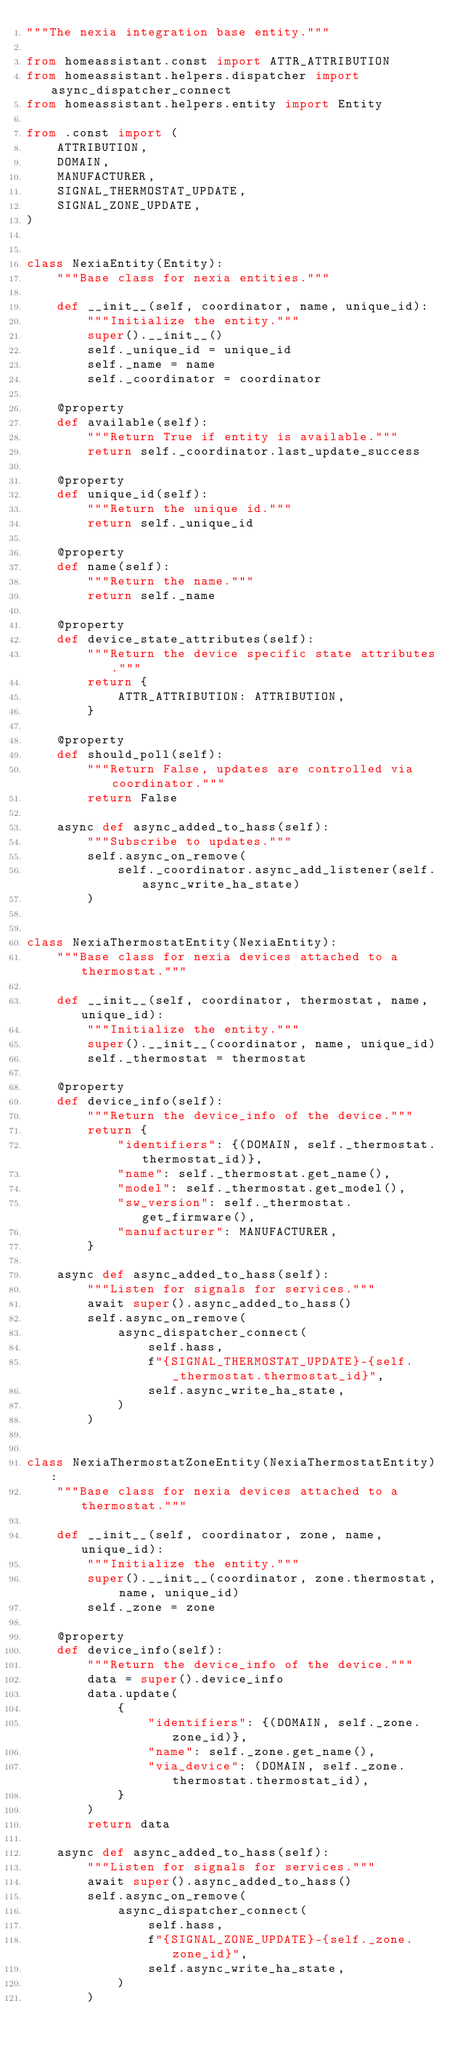<code> <loc_0><loc_0><loc_500><loc_500><_Python_>"""The nexia integration base entity."""

from homeassistant.const import ATTR_ATTRIBUTION
from homeassistant.helpers.dispatcher import async_dispatcher_connect
from homeassistant.helpers.entity import Entity

from .const import (
    ATTRIBUTION,
    DOMAIN,
    MANUFACTURER,
    SIGNAL_THERMOSTAT_UPDATE,
    SIGNAL_ZONE_UPDATE,
)


class NexiaEntity(Entity):
    """Base class for nexia entities."""

    def __init__(self, coordinator, name, unique_id):
        """Initialize the entity."""
        super().__init__()
        self._unique_id = unique_id
        self._name = name
        self._coordinator = coordinator

    @property
    def available(self):
        """Return True if entity is available."""
        return self._coordinator.last_update_success

    @property
    def unique_id(self):
        """Return the unique id."""
        return self._unique_id

    @property
    def name(self):
        """Return the name."""
        return self._name

    @property
    def device_state_attributes(self):
        """Return the device specific state attributes."""
        return {
            ATTR_ATTRIBUTION: ATTRIBUTION,
        }

    @property
    def should_poll(self):
        """Return False, updates are controlled via coordinator."""
        return False

    async def async_added_to_hass(self):
        """Subscribe to updates."""
        self.async_on_remove(
            self._coordinator.async_add_listener(self.async_write_ha_state)
        )


class NexiaThermostatEntity(NexiaEntity):
    """Base class for nexia devices attached to a thermostat."""

    def __init__(self, coordinator, thermostat, name, unique_id):
        """Initialize the entity."""
        super().__init__(coordinator, name, unique_id)
        self._thermostat = thermostat

    @property
    def device_info(self):
        """Return the device_info of the device."""
        return {
            "identifiers": {(DOMAIN, self._thermostat.thermostat_id)},
            "name": self._thermostat.get_name(),
            "model": self._thermostat.get_model(),
            "sw_version": self._thermostat.get_firmware(),
            "manufacturer": MANUFACTURER,
        }

    async def async_added_to_hass(self):
        """Listen for signals for services."""
        await super().async_added_to_hass()
        self.async_on_remove(
            async_dispatcher_connect(
                self.hass,
                f"{SIGNAL_THERMOSTAT_UPDATE}-{self._thermostat.thermostat_id}",
                self.async_write_ha_state,
            )
        )


class NexiaThermostatZoneEntity(NexiaThermostatEntity):
    """Base class for nexia devices attached to a thermostat."""

    def __init__(self, coordinator, zone, name, unique_id):
        """Initialize the entity."""
        super().__init__(coordinator, zone.thermostat, name, unique_id)
        self._zone = zone

    @property
    def device_info(self):
        """Return the device_info of the device."""
        data = super().device_info
        data.update(
            {
                "identifiers": {(DOMAIN, self._zone.zone_id)},
                "name": self._zone.get_name(),
                "via_device": (DOMAIN, self._zone.thermostat.thermostat_id),
            }
        )
        return data

    async def async_added_to_hass(self):
        """Listen for signals for services."""
        await super().async_added_to_hass()
        self.async_on_remove(
            async_dispatcher_connect(
                self.hass,
                f"{SIGNAL_ZONE_UPDATE}-{self._zone.zone_id}",
                self.async_write_ha_state,
            )
        )
</code> 